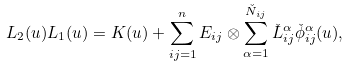<formula> <loc_0><loc_0><loc_500><loc_500>L _ { 2 } ( u ) L _ { 1 } ( u ) = K ( u ) + \sum _ { i j = 1 } ^ { n } E _ { i j } \otimes \sum _ { \alpha = 1 } ^ { \check { N } _ { i j } } \check { L } ^ { \alpha } _ { i j } \check { \phi } ^ { \alpha } _ { i j } ( u ) ,</formula> 